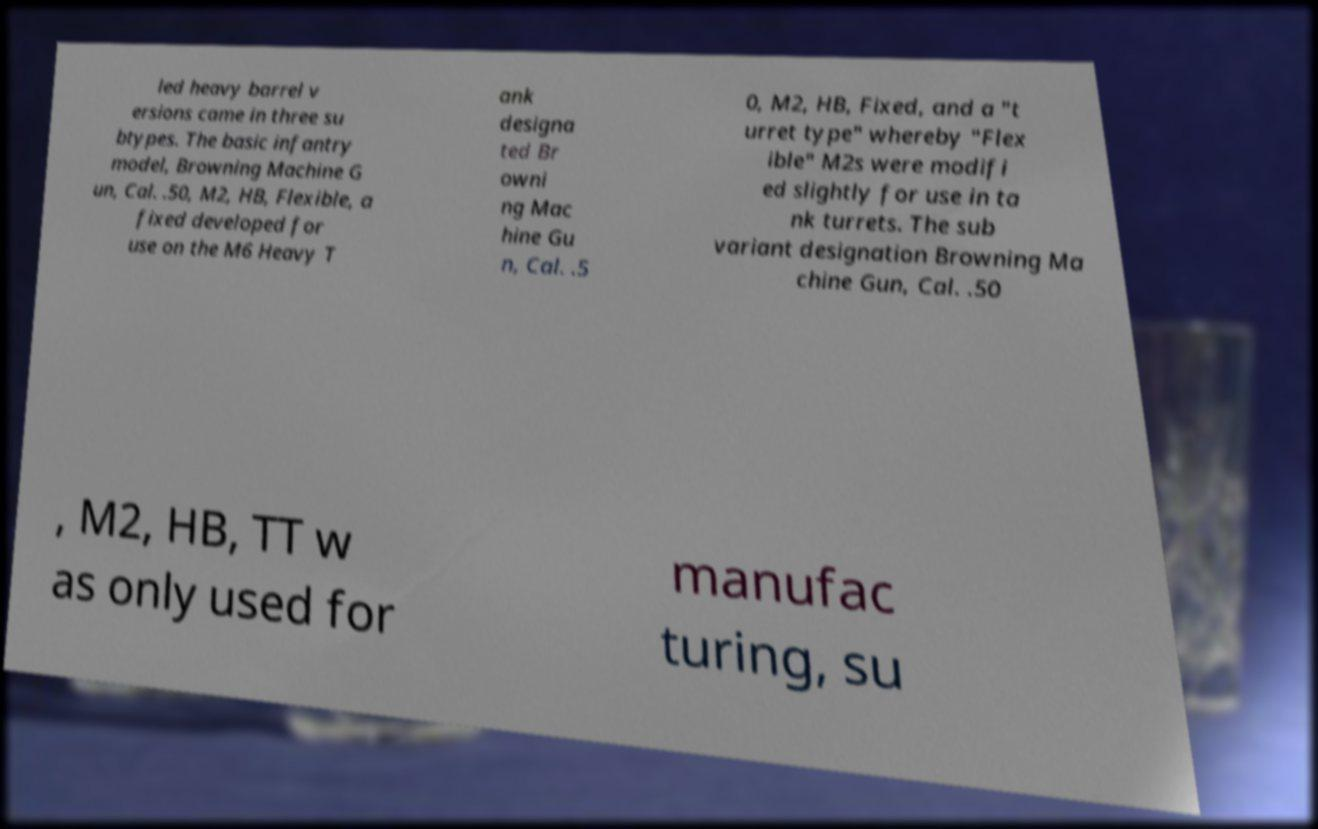Could you extract and type out the text from this image? led heavy barrel v ersions came in three su btypes. The basic infantry model, Browning Machine G un, Cal. .50, M2, HB, Flexible, a fixed developed for use on the M6 Heavy T ank designa ted Br owni ng Mac hine Gu n, Cal. .5 0, M2, HB, Fixed, and a "t urret type" whereby "Flex ible" M2s were modifi ed slightly for use in ta nk turrets. The sub variant designation Browning Ma chine Gun, Cal. .50 , M2, HB, TT w as only used for manufac turing, su 